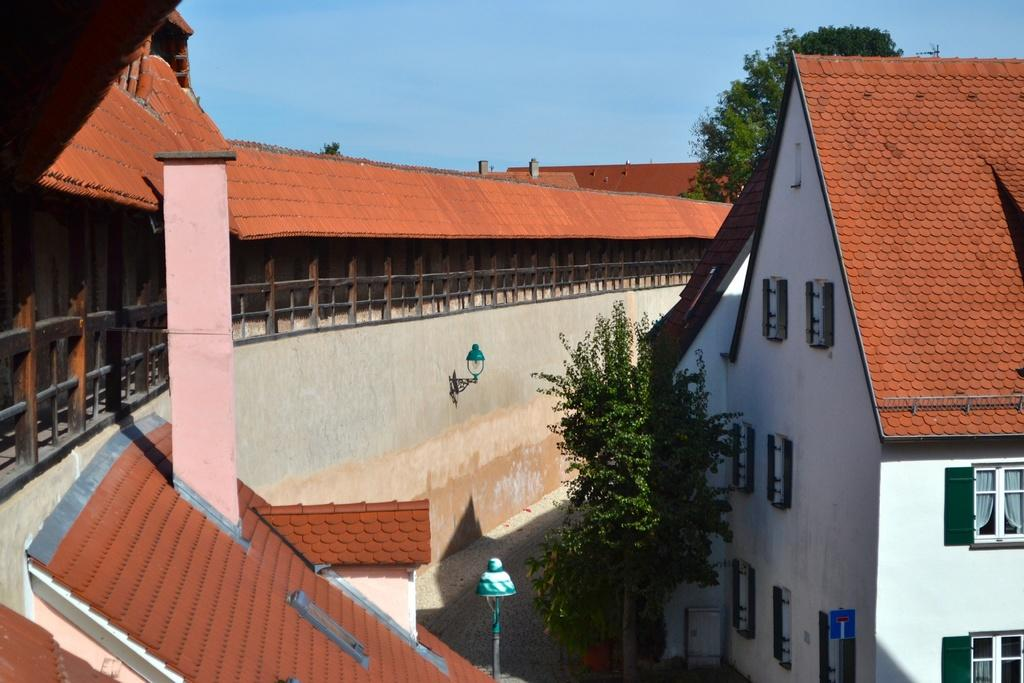What type of structures can be seen in the image? There are buildings in the image. What is located in the center of the image? There is a tree in the center of the image. What is on the left side of the image? There is a fence on the left side of the image. What is present at the back of the image? There is a tree at the back of the image. What is visible at the top of the image? The sky is visible at the top of the image. Can you see the veins of the tree in the image? There is no specific detail about the tree's veins mentioned in the facts, so it cannot be determined from the image. 